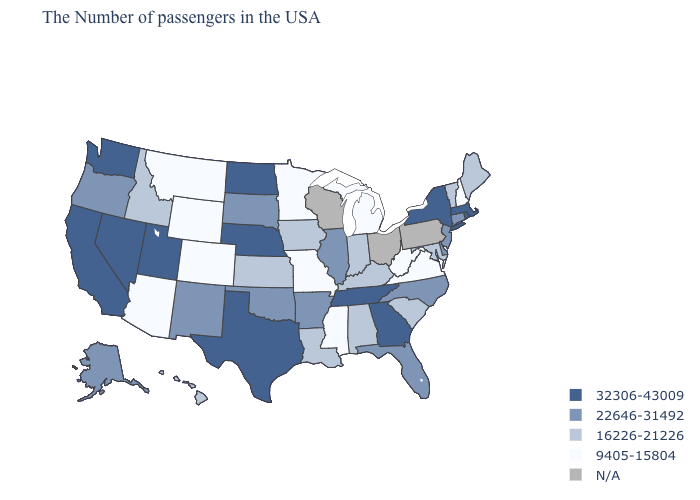What is the value of Hawaii?
Keep it brief. 16226-21226. What is the value of Louisiana?
Write a very short answer. 16226-21226. Name the states that have a value in the range 22646-31492?
Keep it brief. Connecticut, New Jersey, Delaware, North Carolina, Florida, Illinois, Arkansas, Oklahoma, South Dakota, New Mexico, Oregon, Alaska. Which states have the highest value in the USA?
Keep it brief. Massachusetts, Rhode Island, New York, Georgia, Tennessee, Nebraska, Texas, North Dakota, Utah, Nevada, California, Washington. What is the lowest value in the Northeast?
Give a very brief answer. 9405-15804. What is the highest value in the West ?
Quick response, please. 32306-43009. Which states have the lowest value in the USA?
Quick response, please. New Hampshire, Virginia, West Virginia, Michigan, Mississippi, Missouri, Minnesota, Wyoming, Colorado, Montana, Arizona. Does New Mexico have the lowest value in the USA?
Short answer required. No. What is the value of Virginia?
Concise answer only. 9405-15804. Name the states that have a value in the range 22646-31492?
Concise answer only. Connecticut, New Jersey, Delaware, North Carolina, Florida, Illinois, Arkansas, Oklahoma, South Dakota, New Mexico, Oregon, Alaska. Name the states that have a value in the range 9405-15804?
Short answer required. New Hampshire, Virginia, West Virginia, Michigan, Mississippi, Missouri, Minnesota, Wyoming, Colorado, Montana, Arizona. What is the value of New York?
Answer briefly. 32306-43009. What is the value of Maine?
Concise answer only. 16226-21226. Does the map have missing data?
Be succinct. Yes. 